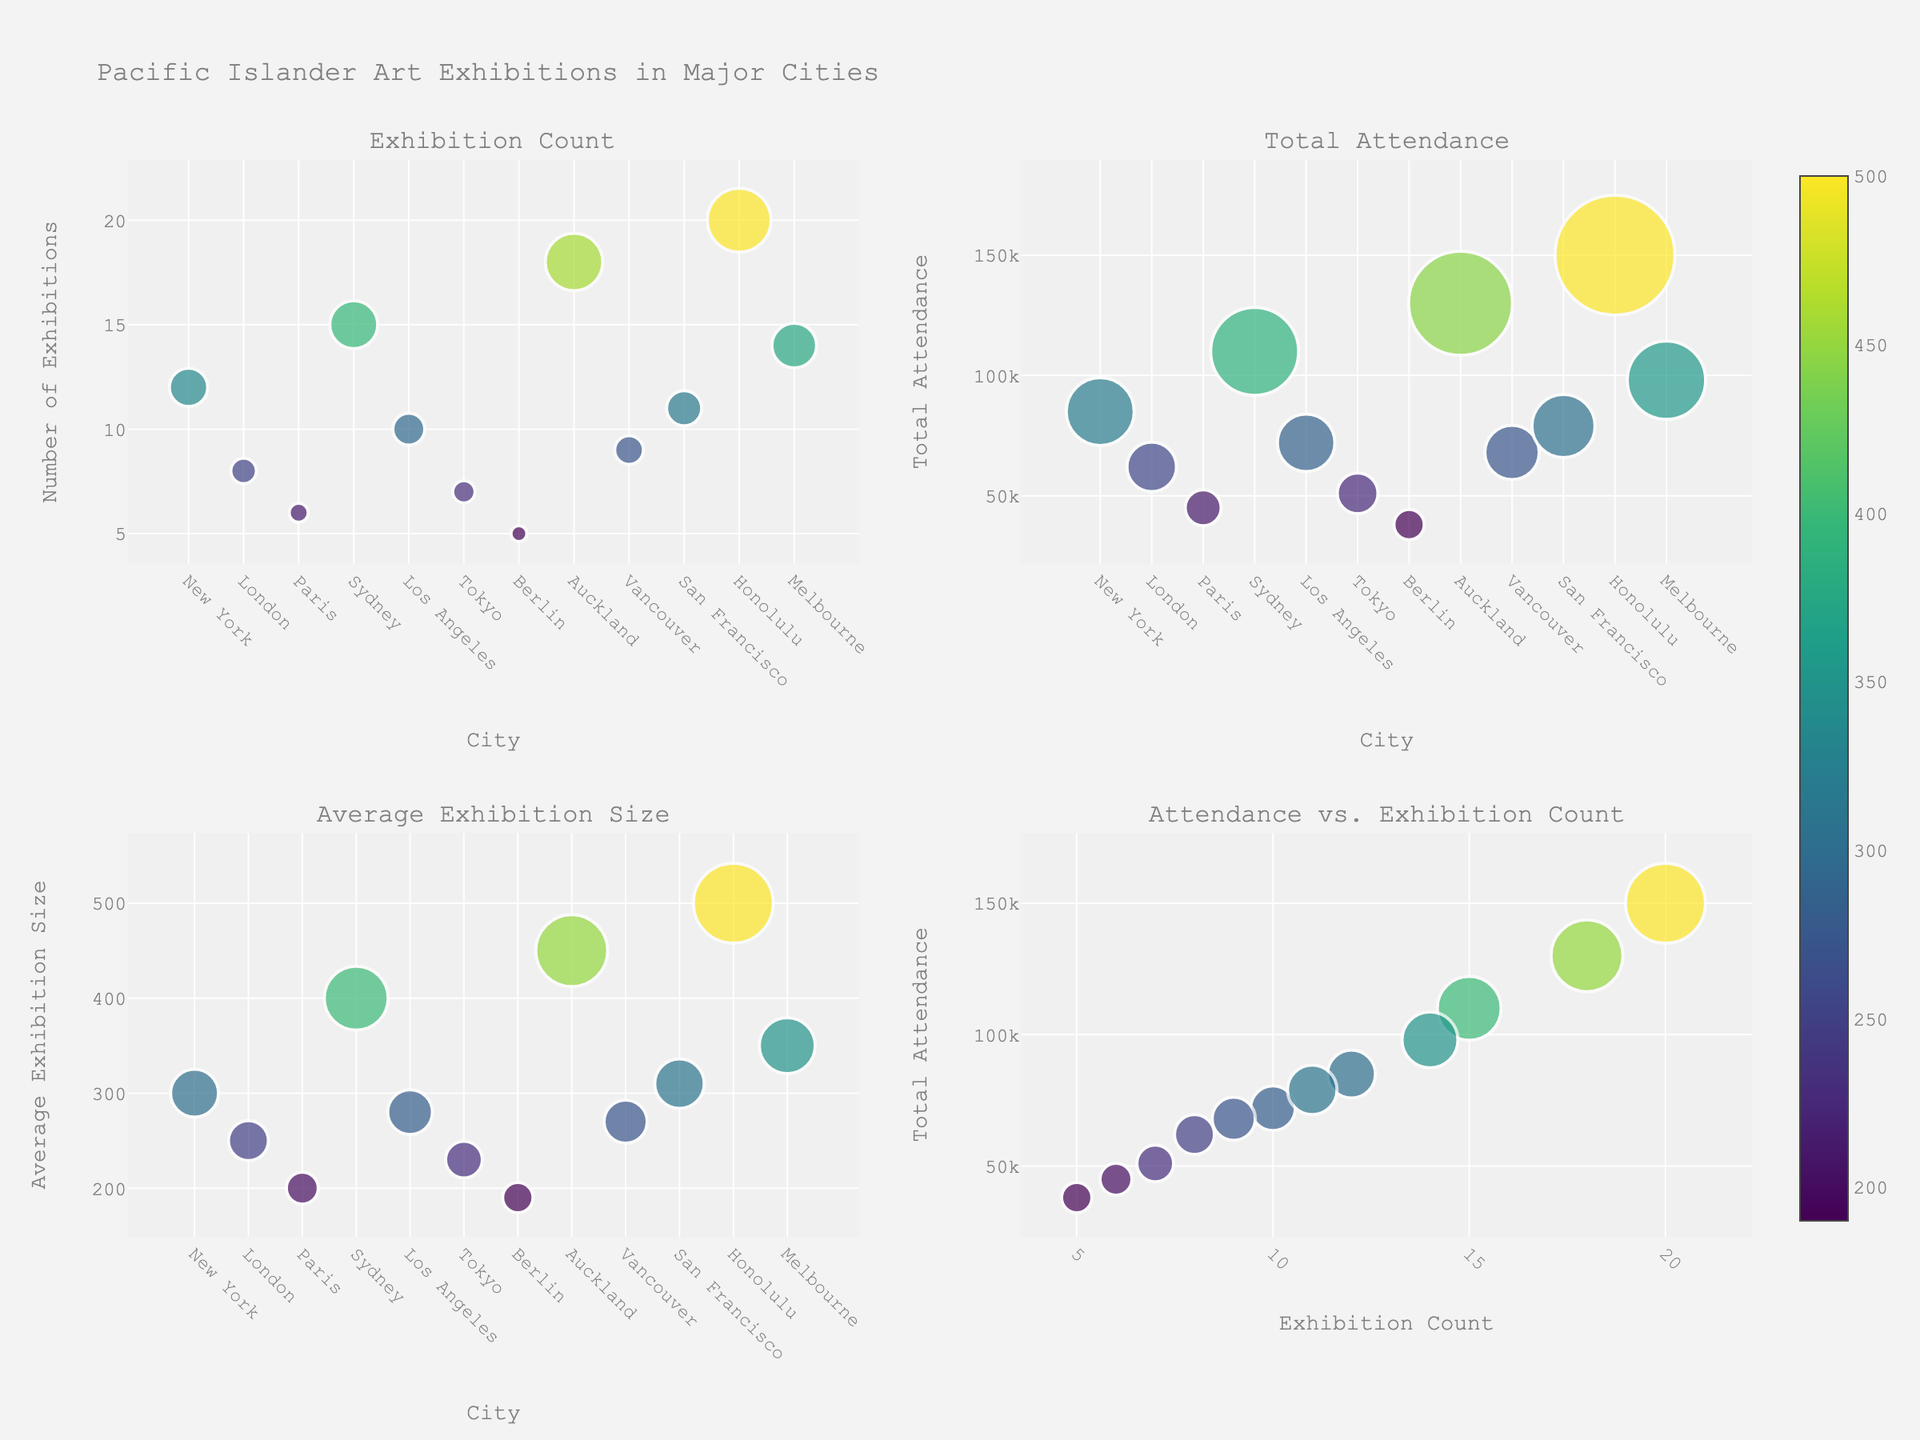What city has the highest total attendance? By looking at the bubble chart for Total Attendance, you can see that Honolulu has the bubble with the largest size, indicating the highest total attendance.
Answer: Honolulu How many exhibitions were held in Auckland? In the Exhibition Count subplot, look for the Auckland bubble and check the y-axis value. The marker at Auckland shows it has an exhibition count of 18.
Answer: 18 Which city has the lowest average exhibition size? In the Average Exhibition Size subplot, identify the smallest marker on the y-axis. This corresponds to Berlin, which has the lowest average exhibition size.
Answer: Berlin What is the average size of exhibitions in Sydney? In the Average Exhibition Size subplot, locate the bubble for Sydney and check the y-axis value. The marker shows an average exhibition size of 400.
Answer: 400 How does the attendance of Honolulu compare to Melbourne? Refer to the Total Attendance subplot and compare the sizes of the bubbles for Honolulu and Melbourne. Honolulu has a visibly larger bubble, indicating higher attendance.
Answer: Honolulu has higher attendance What's the total number of exhibitions across all the cities? Sum the exhibition counts from each city visible on the y-axis of the Exhibition Count subplot: 12+8+6+15+10+7+5+18+9+11+20+14. Adding these numbers gives 135.
Answer: 135 Which city has more exhibitions: Tokyo or Paris? In the Exhibition Count subplot, compare the y-axis values for Tokyo and Paris. Tokyo has 7 exhibitions, while Paris has 6.
Answer: Tokyo Is there a correlation between the number of exhibitions and total attendance? In the Attendance vs. Exhibition Count subplot, observe if there's a trend between the exhibition count (x-axis) and total attendance (y-axis). A positive slope suggests a correlation, as higher exhibition counts generally relate to higher attendance.
Answer: Yes Which city has the highest average exhibition size in the plot? In the Average Exhibition Size subplot, look for the largest marker on the y-axis. The largest bubble corresponds to Honolulu.
Answer: Honolulu 